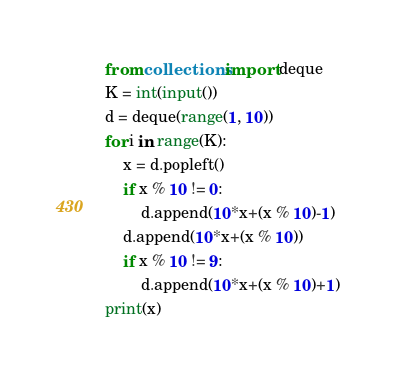<code> <loc_0><loc_0><loc_500><loc_500><_Python_>from collections import deque
K = int(input())
d = deque(range(1, 10))
for i in range(K):
    x = d.popleft()
    if x % 10 != 0:
        d.append(10*x+(x % 10)-1)
    d.append(10*x+(x % 10))
    if x % 10 != 9:
        d.append(10*x+(x % 10)+1)
print(x)</code> 